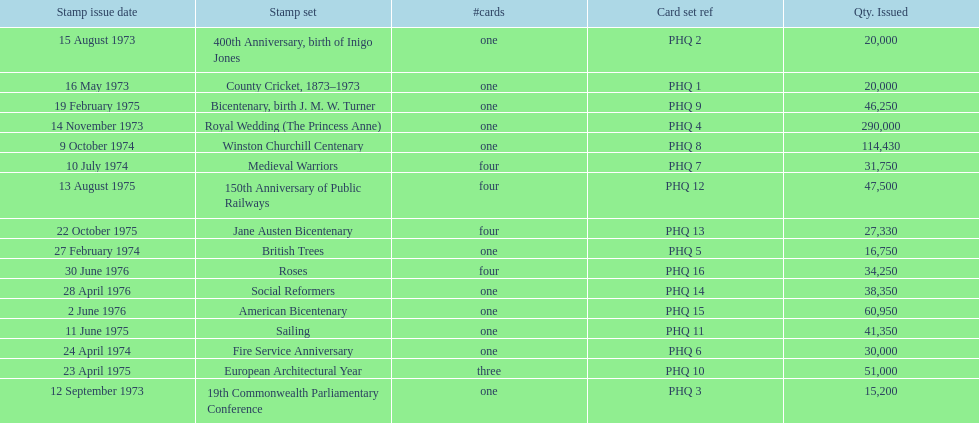Which stamp sets contained more than one card? Medieval Warriors, European Architectural Year, 150th Anniversary of Public Railways, Jane Austen Bicentenary, Roses. Of those stamp sets, which contains a unique number of cards? European Architectural Year. 